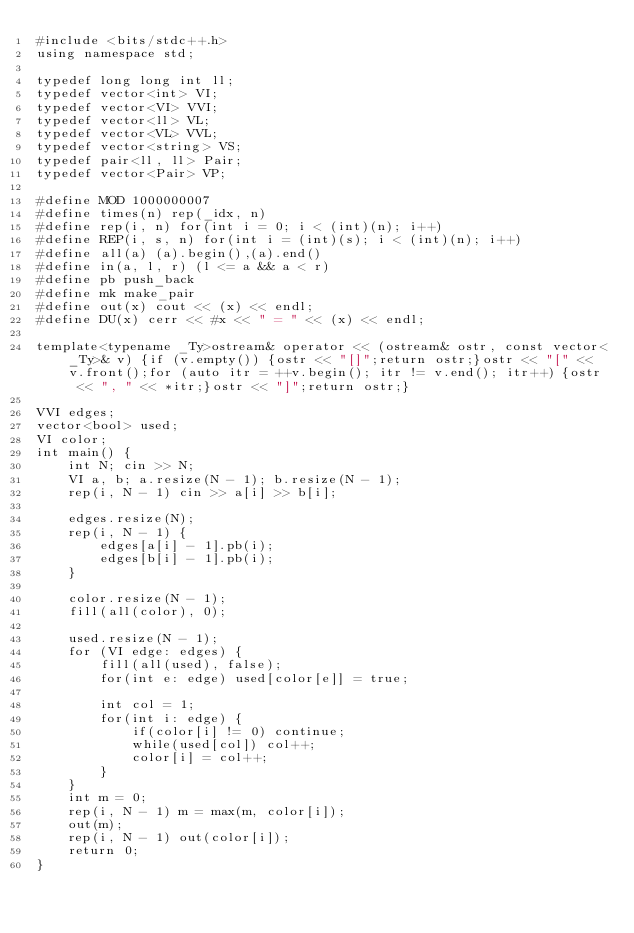Convert code to text. <code><loc_0><loc_0><loc_500><loc_500><_C++_>#include <bits/stdc++.h>
using namespace std;

typedef long long int ll;
typedef vector<int> VI;
typedef vector<VI> VVI;
typedef vector<ll> VL;
typedef vector<VL> VVL;
typedef vector<string> VS;
typedef pair<ll, ll> Pair;
typedef vector<Pair> VP;

#define MOD 1000000007
#define times(n) rep(_idx, n)
#define rep(i, n) for(int i = 0; i < (int)(n); i++)
#define REP(i, s, n) for(int i = (int)(s); i < (int)(n); i++)
#define all(a) (a).begin(),(a).end()
#define in(a, l, r) (l <= a && a < r)
#define pb push_back
#define mk make_pair
#define out(x) cout << (x) << endl;
#define DU(x) cerr << #x << " = " << (x) << endl;

template<typename _Ty>ostream& operator << (ostream& ostr, const vector<_Ty>& v) {if (v.empty()) {ostr << "[]";return ostr;}ostr << "[" << v.front();for (auto itr = ++v.begin(); itr != v.end(); itr++) {ostr << ", " << *itr;}ostr << "]";return ostr;}

VVI edges;
vector<bool> used;
VI color; 
int main() {
    int N; cin >> N;
    VI a, b; a.resize(N - 1); b.resize(N - 1);
    rep(i, N - 1) cin >> a[i] >> b[i];

    edges.resize(N);
    rep(i, N - 1) {
        edges[a[i] - 1].pb(i);
        edges[b[i] - 1].pb(i);
    }

    color.resize(N - 1);
    fill(all(color), 0);

    used.resize(N - 1);
    for (VI edge: edges) {
        fill(all(used), false);
        for(int e: edge) used[color[e]] = true;
        
        int col = 1;
        for(int i: edge) {
            if(color[i] != 0) continue;
            while(used[col]) col++;
            color[i] = col++;
        }
    }
    int m = 0;
    rep(i, N - 1) m = max(m, color[i]);
    out(m);
    rep(i, N - 1) out(color[i]);
    return 0;
}
</code> 